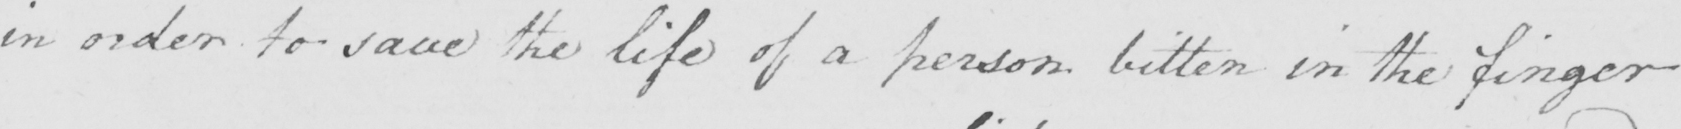Please provide the text content of this handwritten line. in order to save the life of a person bitten in the finger 